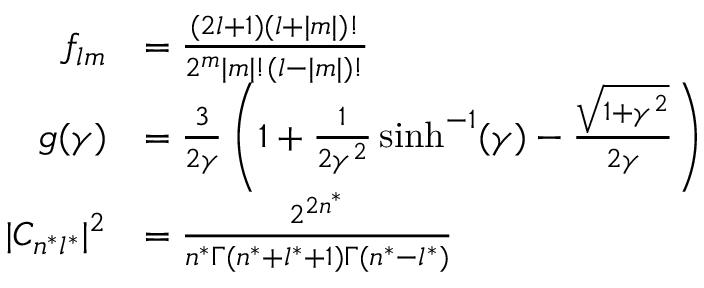Convert formula to latex. <formula><loc_0><loc_0><loc_500><loc_500>{ \begin{array} { r l } { f _ { l m } } & { = { \frac { ( 2 l + 1 ) ( l + | m | ) ! } { 2 ^ { m } | m | ! ( l - | m | ) ! } } } \\ { g ( \gamma ) } & { = { \frac { 3 } { 2 \gamma } } \left ( 1 + { \frac { 1 } { 2 \gamma ^ { 2 } } } \sinh ^ { - 1 } ( \gamma ) - { \frac { \sqrt { 1 + \gamma ^ { 2 } } } { 2 \gamma } } \right ) } \\ { | C _ { n ^ { * } l ^ { * } } | ^ { 2 } } & { = { \frac { 2 ^ { 2 n ^ { * } } } { n ^ { * } \Gamma ( n ^ { * } + l ^ { * } + 1 ) \Gamma ( n ^ { * } - l ^ { * } ) } } } \end{array} }</formula> 